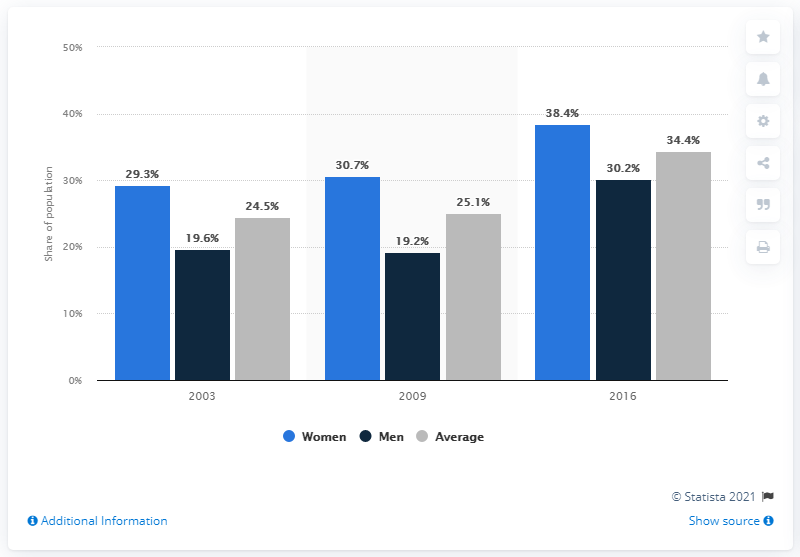Give some essential details in this illustration. According to a study conducted in 2016, 38.4% of women in Chile had a body mass index (BMI) of more than 30 kilograms per square meter, which indicates obesity. Men have the lowest percentage of the population among all genders. The obesity rate increased among both men and women in Chile in the year 2003. In 2016, the obesity rate among men in Chile was 30.2%. In 2016, men accounted for the highest percentage of the global population. 